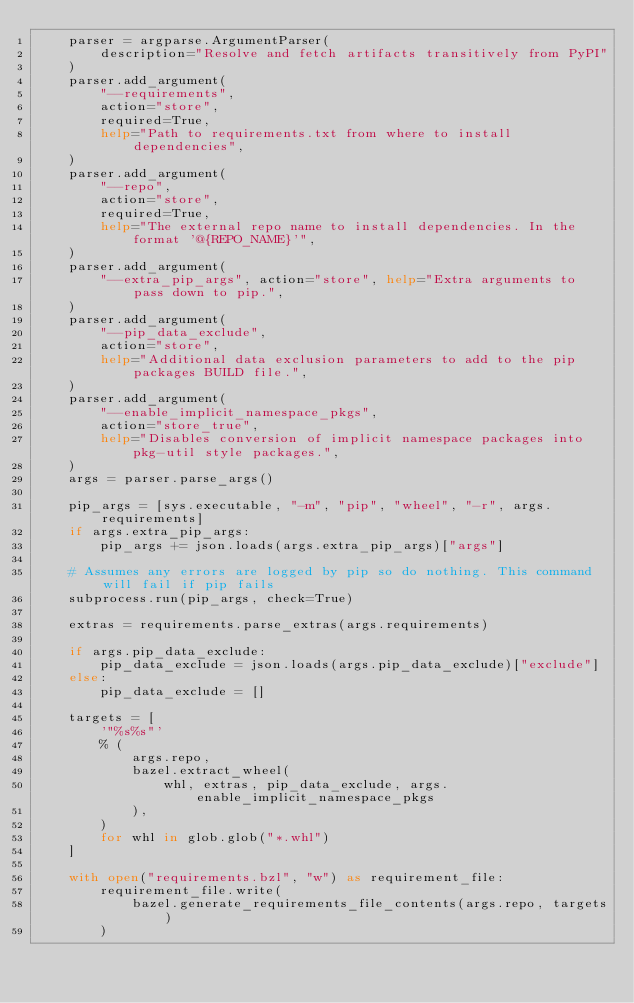Convert code to text. <code><loc_0><loc_0><loc_500><loc_500><_Python_>    parser = argparse.ArgumentParser(
        description="Resolve and fetch artifacts transitively from PyPI"
    )
    parser.add_argument(
        "--requirements",
        action="store",
        required=True,
        help="Path to requirements.txt from where to install dependencies",
    )
    parser.add_argument(
        "--repo",
        action="store",
        required=True,
        help="The external repo name to install dependencies. In the format '@{REPO_NAME}'",
    )
    parser.add_argument(
        "--extra_pip_args", action="store", help="Extra arguments to pass down to pip.",
    )
    parser.add_argument(
        "--pip_data_exclude",
        action="store",
        help="Additional data exclusion parameters to add to the pip packages BUILD file.",
    )
    parser.add_argument(
        "--enable_implicit_namespace_pkgs",
        action="store_true",
        help="Disables conversion of implicit namespace packages into pkg-util style packages.",
    )
    args = parser.parse_args()

    pip_args = [sys.executable, "-m", "pip", "wheel", "-r", args.requirements]
    if args.extra_pip_args:
        pip_args += json.loads(args.extra_pip_args)["args"]

    # Assumes any errors are logged by pip so do nothing. This command will fail if pip fails
    subprocess.run(pip_args, check=True)

    extras = requirements.parse_extras(args.requirements)

    if args.pip_data_exclude:
        pip_data_exclude = json.loads(args.pip_data_exclude)["exclude"]
    else:
        pip_data_exclude = []

    targets = [
        '"%s%s"'
        % (
            args.repo,
            bazel.extract_wheel(
                whl, extras, pip_data_exclude, args.enable_implicit_namespace_pkgs
            ),
        )
        for whl in glob.glob("*.whl")
    ]

    with open("requirements.bzl", "w") as requirement_file:
        requirement_file.write(
            bazel.generate_requirements_file_contents(args.repo, targets)
        )
</code> 